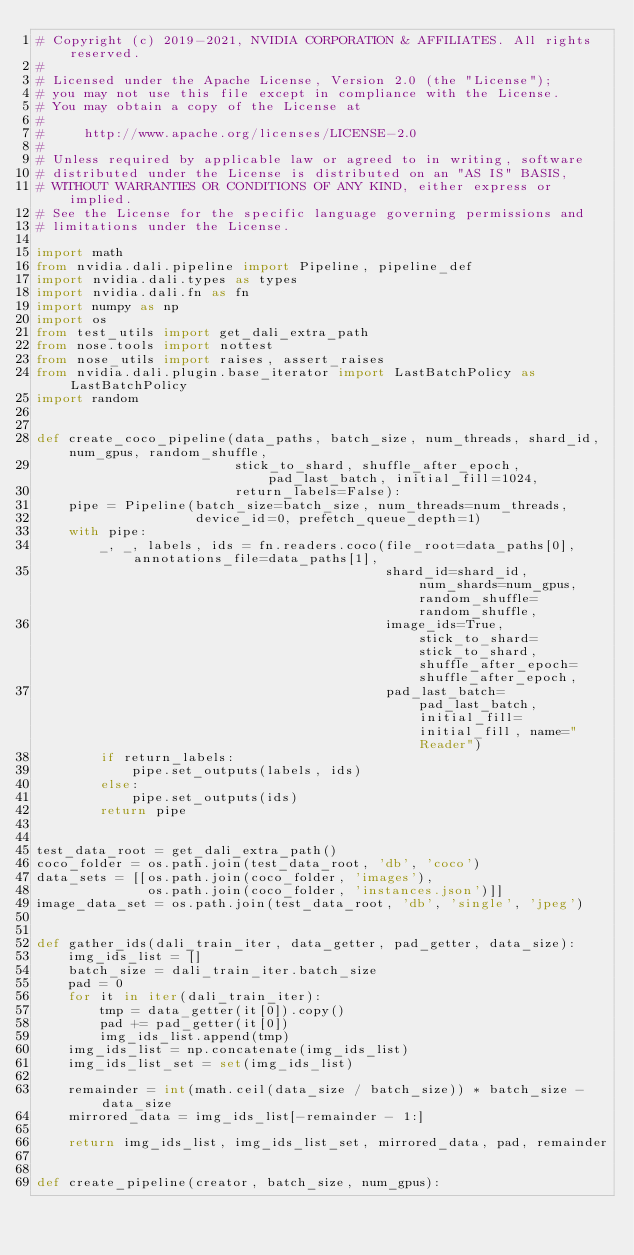Convert code to text. <code><loc_0><loc_0><loc_500><loc_500><_Python_># Copyright (c) 2019-2021, NVIDIA CORPORATION & AFFILIATES. All rights reserved.
#
# Licensed under the Apache License, Version 2.0 (the "License");
# you may not use this file except in compliance with the License.
# You may obtain a copy of the License at
#
#     http://www.apache.org/licenses/LICENSE-2.0
#
# Unless required by applicable law or agreed to in writing, software
# distributed under the License is distributed on an "AS IS" BASIS,
# WITHOUT WARRANTIES OR CONDITIONS OF ANY KIND, either express or implied.
# See the License for the specific language governing permissions and
# limitations under the License.

import math
from nvidia.dali.pipeline import Pipeline, pipeline_def
import nvidia.dali.types as types
import nvidia.dali.fn as fn
import numpy as np
import os
from test_utils import get_dali_extra_path
from nose.tools import nottest
from nose_utils import raises, assert_raises
from nvidia.dali.plugin.base_iterator import LastBatchPolicy as LastBatchPolicy
import random


def create_coco_pipeline(data_paths, batch_size, num_threads, shard_id, num_gpus, random_shuffle,
                         stick_to_shard, shuffle_after_epoch, pad_last_batch, initial_fill=1024,
                         return_labels=False):
    pipe = Pipeline(batch_size=batch_size, num_threads=num_threads,
                    device_id=0, prefetch_queue_depth=1)
    with pipe:
        _, _, labels, ids = fn.readers.coco(file_root=data_paths[0], annotations_file=data_paths[1],
                                            shard_id=shard_id, num_shards=num_gpus, random_shuffle=random_shuffle,
                                            image_ids=True, stick_to_shard=stick_to_shard, shuffle_after_epoch=shuffle_after_epoch,
                                            pad_last_batch=pad_last_batch, initial_fill=initial_fill, name="Reader")
        if return_labels:
            pipe.set_outputs(labels, ids)
        else:
            pipe.set_outputs(ids)
        return pipe


test_data_root = get_dali_extra_path()
coco_folder = os.path.join(test_data_root, 'db', 'coco')
data_sets = [[os.path.join(coco_folder, 'images'),
              os.path.join(coco_folder, 'instances.json')]]
image_data_set = os.path.join(test_data_root, 'db', 'single', 'jpeg')


def gather_ids(dali_train_iter, data_getter, pad_getter, data_size):
    img_ids_list = []
    batch_size = dali_train_iter.batch_size
    pad = 0
    for it in iter(dali_train_iter):
        tmp = data_getter(it[0]).copy()
        pad += pad_getter(it[0])
        img_ids_list.append(tmp)
    img_ids_list = np.concatenate(img_ids_list)
    img_ids_list_set = set(img_ids_list)

    remainder = int(math.ceil(data_size / batch_size)) * batch_size - data_size
    mirrored_data = img_ids_list[-remainder - 1:]

    return img_ids_list, img_ids_list_set, mirrored_data, pad, remainder


def create_pipeline(creator, batch_size, num_gpus):</code> 